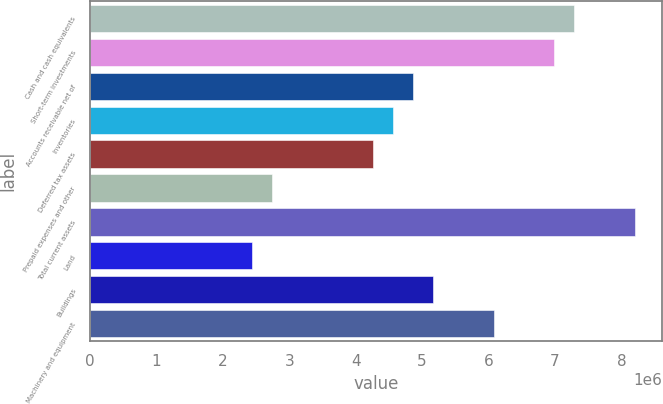Convert chart to OTSL. <chart><loc_0><loc_0><loc_500><loc_500><bar_chart><fcel>Cash and cash equivalents<fcel>Short-term investments<fcel>Accounts receivable net of<fcel>Inventories<fcel>Deferred tax assets<fcel>Prepaid expenses and other<fcel>Total current assets<fcel>Land<fcel>Buildings<fcel>Machinery and equipment<nl><fcel>7.29378e+06<fcel>6.98989e+06<fcel>4.86259e+06<fcel>4.55869e+06<fcel>4.25479e+06<fcel>2.7353e+06<fcel>8.20548e+06<fcel>2.4314e+06<fcel>5.16649e+06<fcel>6.07819e+06<nl></chart> 